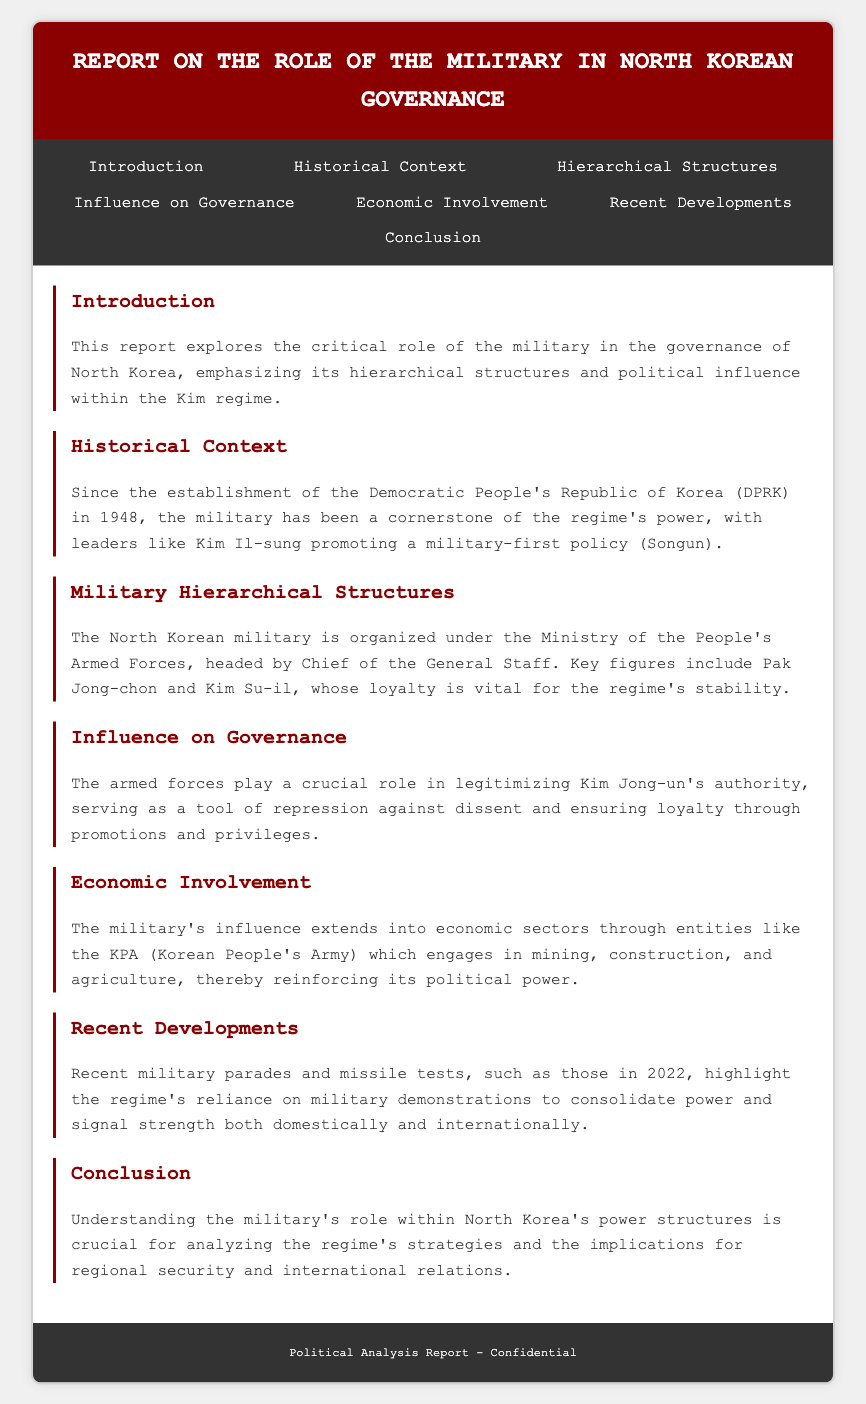what is the primary focus of the report? The report emphasizes the role of the military in governance structures within the Kim regime, particularly its hierarchical influence.
Answer: military governance who established the Democratic People's Republic of Korea (DPRK)? The document states that the DPRK was established in 1948, referring to Kim Il-sung's regime.
Answer: Kim Il-sung what policy did Kim Il-sung promote regarding military influence? The report highlights that Kim Il-sung promoted a military-first policy known as Songun.
Answer: Songun who heads the Ministry of the People's Armed Forces? The document indicates that the Chief of the General Staff is the head of the Ministry of the People's Armed Forces.
Answer: Chief of the General Staff which key figures are mentioned as important for regime stability? The report lists Pak Jong-chon and Kim Su-il as key figures whose loyalty is vital for the regime.
Answer: Pak Jong-chon and Kim Su-il how does the military legitimize Kim Jong-un's authority? The report states that the armed forces serve as a tool of repression against dissent and ensure loyalty through promotions.
Answer: repression and promotions in what economic sectors does the military have influence? The document mentions that the military engages in mining, construction, and agriculture, reflecting its economic involvement.
Answer: mining, construction, agriculture what significant events occurred in 2022 related to the military? The report points out recent military parades and missile tests as highlights of 2022, emphasizing military demonstrations.
Answer: military parades and missile tests what is the conclusion about the military's role in North Korea? The report concludes that understanding the military's role is crucial for analyzing the regime's strategies impacting regional security.
Answer: crucial for analyzing strategies 